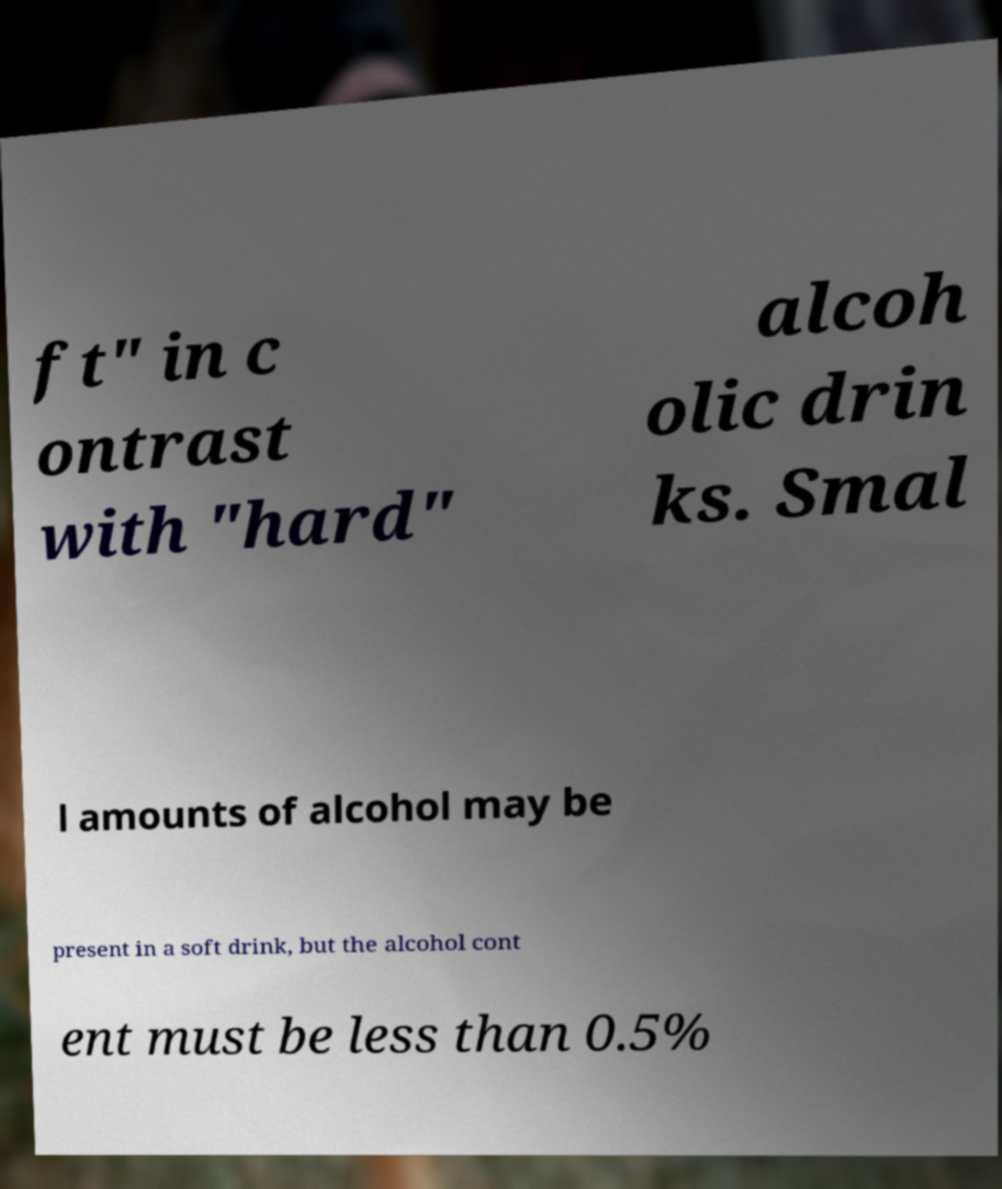Please identify and transcribe the text found in this image. ft" in c ontrast with "hard" alcoh olic drin ks. Smal l amounts of alcohol may be present in a soft drink, but the alcohol cont ent must be less than 0.5% 